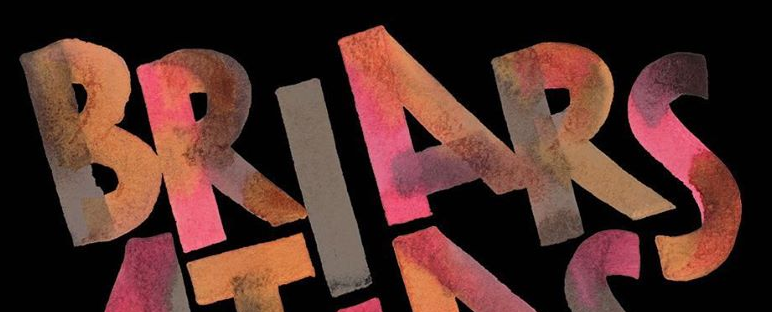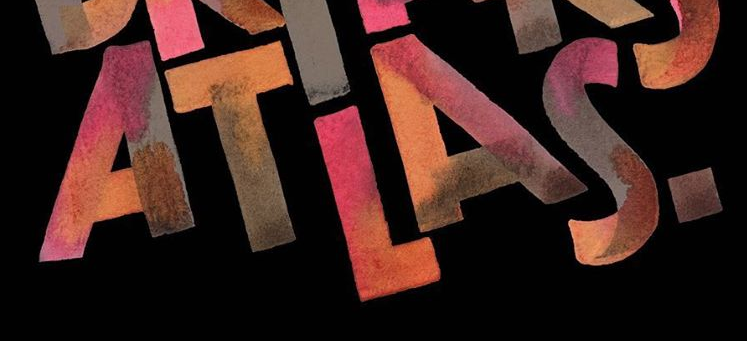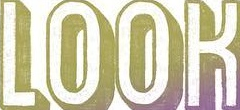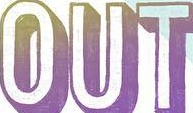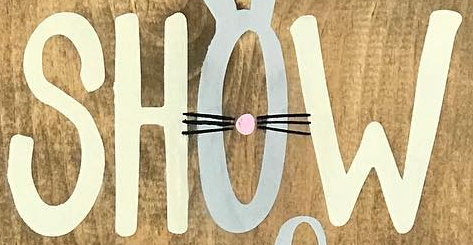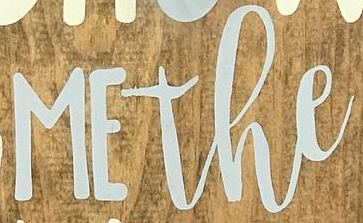What text is displayed in these images sequentially, separated by a semicolon? BRIARS; ATLAS.; LOOK; OUT; SHOW; MEthe 